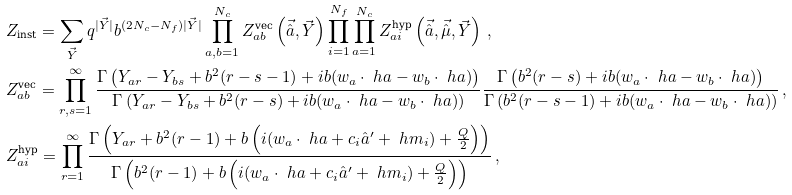Convert formula to latex. <formula><loc_0><loc_0><loc_500><loc_500>& Z _ { \text {inst} } = \sum _ { \vec { Y } } q ^ { | \vec { Y } | } b ^ { ( 2 N _ { c } - N _ { f } ) { | \vec { Y } | } } \prod _ { a , b = 1 } ^ { N _ { c } } Z _ { a b } ^ { \text {vec} } \left ( { \vec { \hat { a } } , \vec { Y } } \right ) \prod _ { i = 1 } ^ { N _ { f } } \prod _ { a = 1 } ^ { N _ { c } } Z _ { a i } ^ { \text {hyp} } \left ( { \vec { \hat { a } } , \vec { \hat { \mu } } , \vec { Y } } \right ) \, , \\ & Z _ { a b } ^ { \text {vec} } = \prod _ { r , s = 1 } ^ { \infty } \frac { \Gamma \left ( Y _ { a r } - Y _ { b s } + b ^ { 2 } ( r - s - 1 ) + i b ( w _ { a } \cdot \ h a - w _ { b } \cdot \ h a ) \right ) } { \Gamma \left ( Y _ { a r } - Y _ { b s } + b ^ { 2 } ( r - s ) + i b ( w _ { a } \cdot \ h a - w _ { b } \cdot \ h a ) \right ) } \frac { \Gamma \left ( b ^ { 2 } ( r - s ) + i b ( w _ { a } \cdot \ h a - w _ { b } \cdot \ h a ) \right ) } { \Gamma \left ( b ^ { 2 } ( r - s - 1 ) + i b ( w _ { a } \cdot \ h a - w _ { b } \cdot \ h a ) \right ) } \, , \\ & Z _ { a i } ^ { \text {hyp} } = \prod _ { r = 1 } ^ { \infty } \frac { \Gamma \left ( Y _ { a r } + b ^ { 2 } ( r - 1 ) + b \left ( i ( w _ { a } \cdot \ h a + c _ { i } \hat { a } ^ { \prime } + \ h m _ { i } ) + \frac { Q } { 2 } \right ) \right ) } { \Gamma \left ( b ^ { 2 } ( r - 1 ) + b \left ( i ( w _ { a } \cdot \ h a + c _ { i } \hat { a } ^ { \prime } + \ h m _ { i } ) + \frac { Q } { 2 } \right ) \right ) } \, ,</formula> 